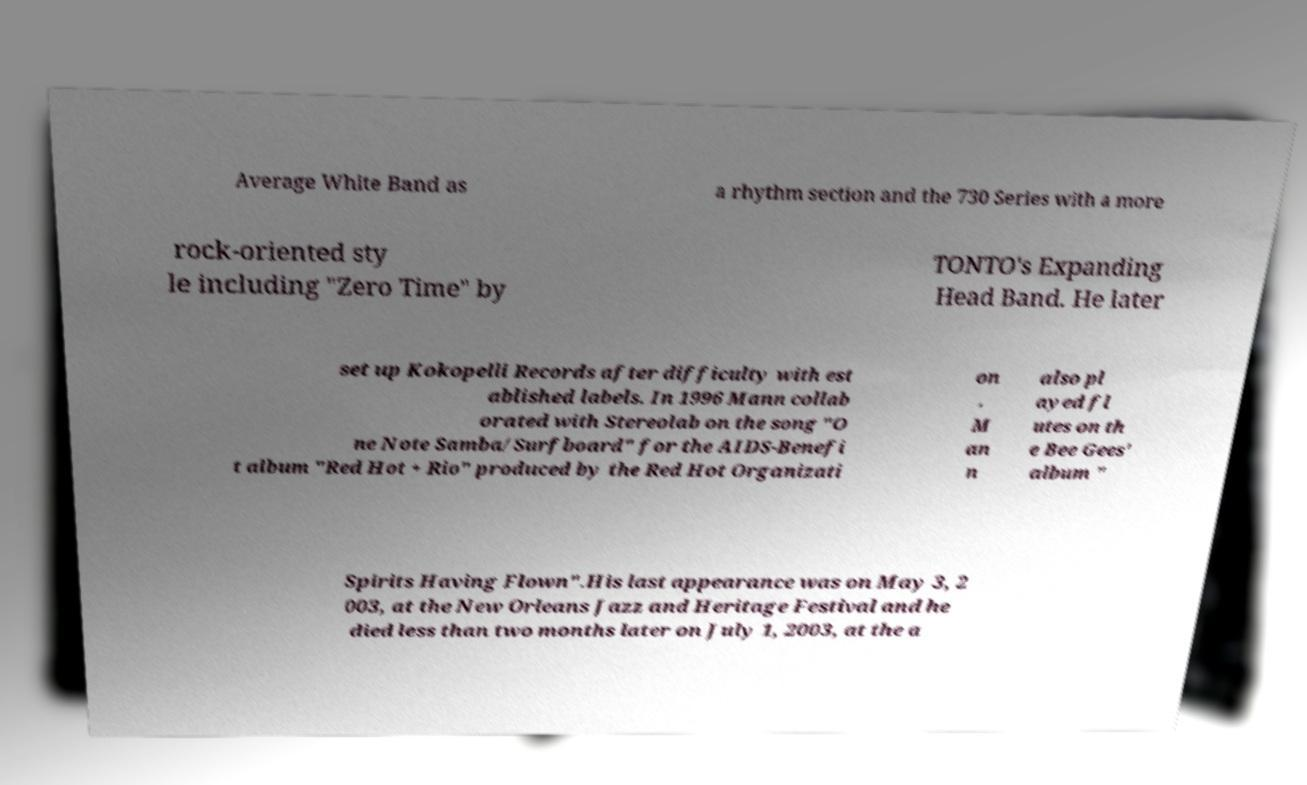Could you assist in decoding the text presented in this image and type it out clearly? Average White Band as a rhythm section and the 730 Series with a more rock-oriented sty le including "Zero Time" by TONTO's Expanding Head Band. He later set up Kokopelli Records after difficulty with est ablished labels. In 1996 Mann collab orated with Stereolab on the song "O ne Note Samba/Surfboard" for the AIDS-Benefi t album "Red Hot + Rio" produced by the Red Hot Organizati on . M an n also pl ayed fl utes on th e Bee Gees' album " Spirits Having Flown".His last appearance was on May 3, 2 003, at the New Orleans Jazz and Heritage Festival and he died less than two months later on July 1, 2003, at the a 